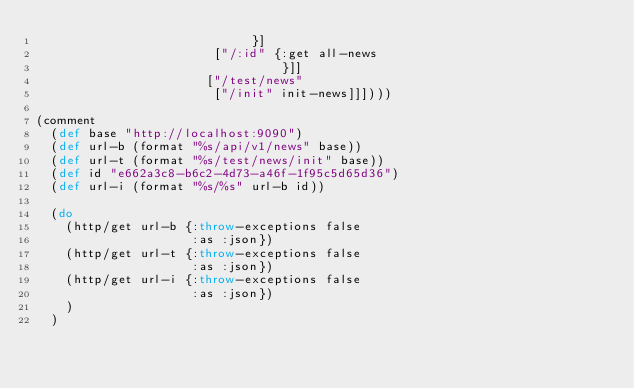Convert code to text. <code><loc_0><loc_0><loc_500><loc_500><_Clojure_>                             }]
                        ["/:id" {:get all-news
                                 }]]
                       ["/test/news"
                        ["/init" init-news]]])))

(comment
  (def base "http://localhost:9090")
  (def url-b (format "%s/api/v1/news" base))
  (def url-t (format "%s/test/news/init" base))
  (def id "e662a3c8-b6c2-4d73-a46f-1f95c5d65d36")
  (def url-i (format "%s/%s" url-b id))

  (do
    (http/get url-b {:throw-exceptions false
                     :as :json})
    (http/get url-t {:throw-exceptions false
                     :as :json})
    (http/get url-i {:throw-exceptions false
                     :as :json})
    )
  )</code> 